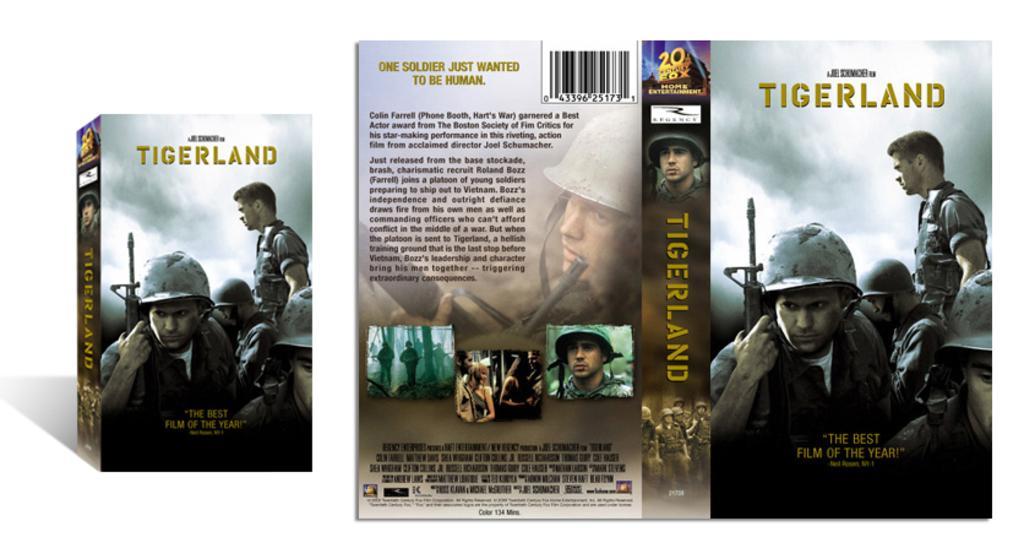How would you summarize this image in a sentence or two? This is a cover page on which 'tiger land' is written. There are people and the background is white. 